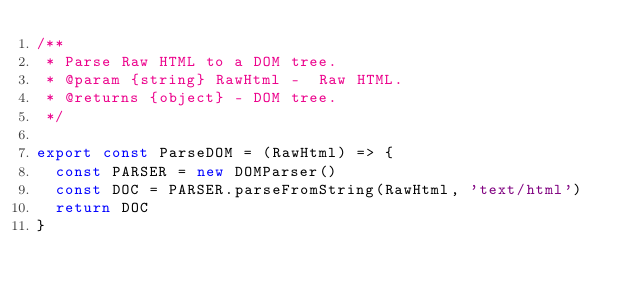<code> <loc_0><loc_0><loc_500><loc_500><_JavaScript_>/**
 * Parse Raw HTML to a DOM tree.
 * @param {string} RawHtml -  Raw HTML.
 * @returns {object} - DOM tree.
 */

export const ParseDOM = (RawHtml) => {
  const PARSER = new DOMParser()
  const DOC = PARSER.parseFromString(RawHtml, 'text/html')
  return DOC
}
</code> 